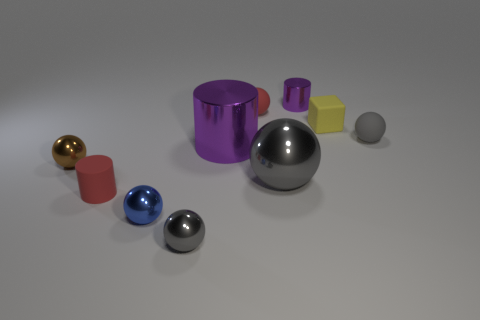What could these objects be used for in a real-world setting? The objects appear to be geometric models commonly used in 3D rendering practice. In a real-world context, they could serve as visual aids for educational purposes in geometry, props for a still life painting or photography setup, or as decorative pieces for artistic display. 